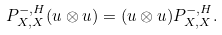Convert formula to latex. <formula><loc_0><loc_0><loc_500><loc_500>P _ { X , X } ^ { - , H } ( u \otimes u ) = ( u \otimes u ) P _ { X , X } ^ { - , H } .</formula> 